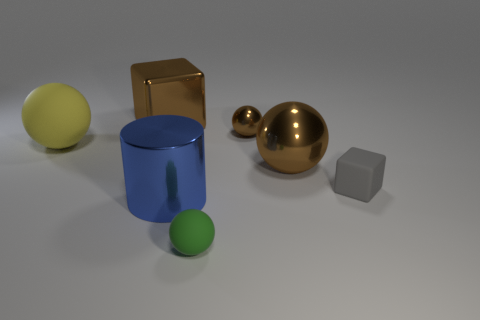What number of metallic things are the same size as the gray block?
Offer a very short reply. 1. There is another shiny ball that is the same color as the large metal ball; what size is it?
Your response must be concise. Small. What number of tiny objects are either green rubber things or metal cylinders?
Your answer should be very brief. 1. How many objects are there?
Make the answer very short. 7. Is the number of tiny objects right of the green matte sphere the same as the number of big things in front of the big yellow matte sphere?
Make the answer very short. Yes. There is a yellow rubber object; are there any cylinders in front of it?
Ensure brevity in your answer.  Yes. The ball left of the large blue thing is what color?
Offer a terse response. Yellow. The big sphere that is left of the matte ball in front of the big yellow rubber ball is made of what material?
Make the answer very short. Rubber. Is the number of big balls to the left of the large blue metallic cylinder less than the number of spheres that are to the left of the small brown metallic ball?
Give a very brief answer. Yes. What number of brown objects are big metal balls or big shiny things?
Ensure brevity in your answer.  2. 